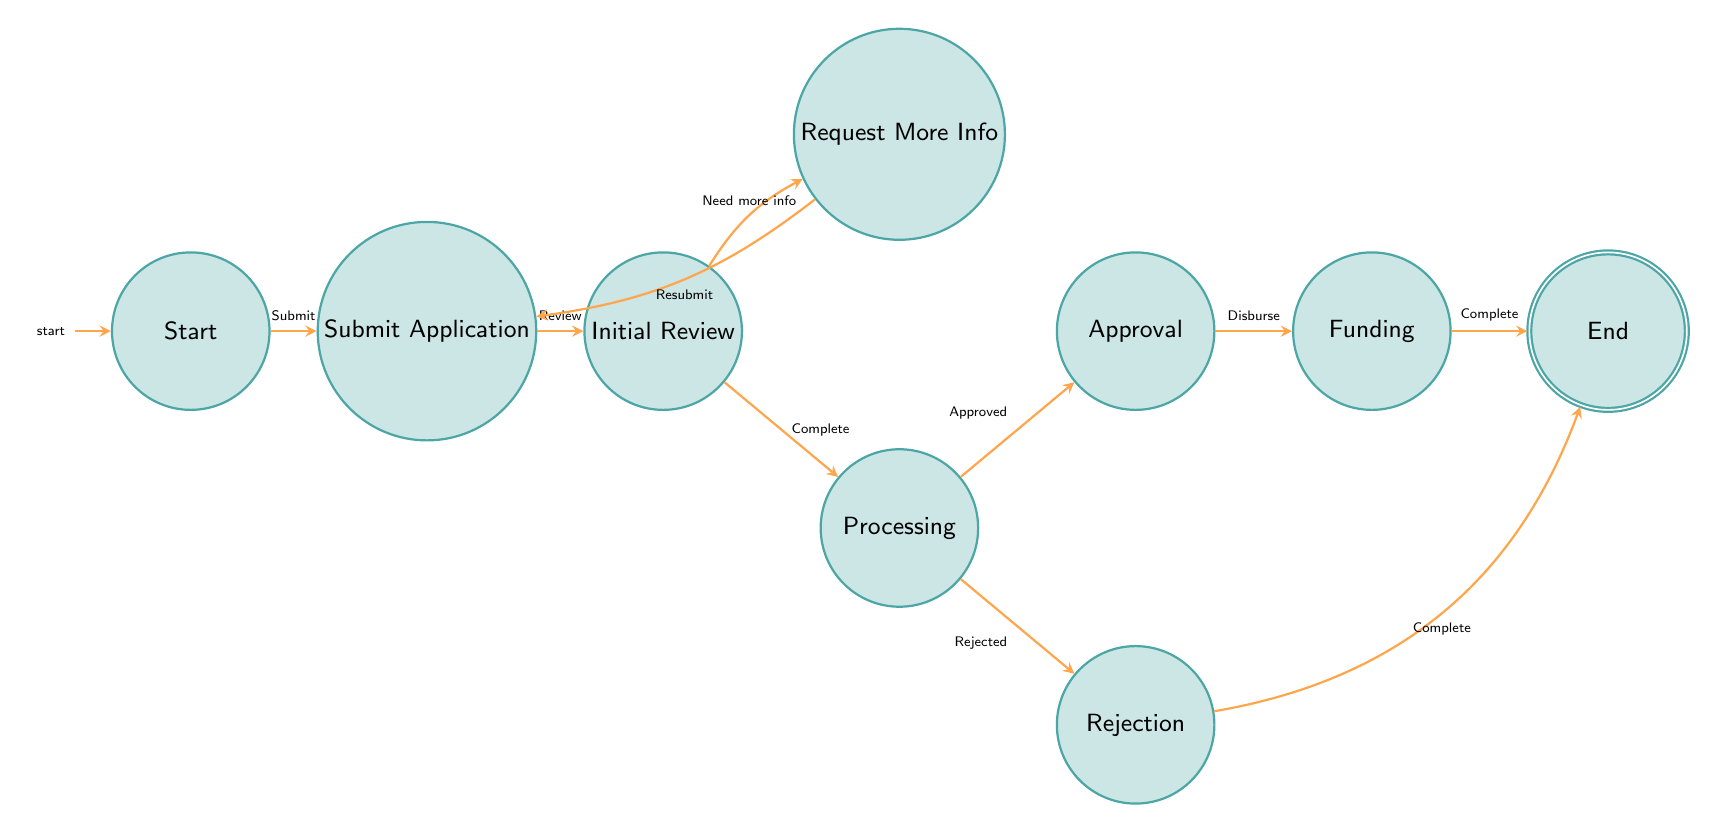What is the initial state of the workflow? The diagram begins at the state labeled "Start," which signifies the initial state of the workflow.
Answer: Start How many total states are there in the diagram? Counting each node in the diagram, there are a total of nine states.
Answer: Nine What follows the "Submit Application" state? After the "Submit Application" state, the workflow moves to the "Initial Review" state.
Answer: Initial Review What state represents loan approval? The state that indicates the loan application has been approved is labeled "Approval."
Answer: Approval What happens after the "Approval" state? Following the "Approval" state, the process transitions to the "Funding" state where the approved loan is disbursed.
Answer: Funding Which state is reached if the application is rejected? If the application is not approved, the process goes to the "Rejection" state.
Answer: Rejection What action leads to the "Request More Information" state? The action requiring additional documents leads to the "Request More Information" state after the "Initial Review."
Answer: Need more info How many transitions occur from the "Processing" state? There are two transitions that occur from the "Processing" state: one to "Approval" and another to "Rejection."
Answer: Two What is the final state of the workflow? The endpoint of the workflow is the state labeled "End," which signifies that the entire process is completed.
Answer: End 